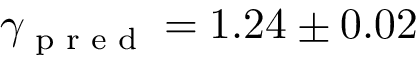Convert formula to latex. <formula><loc_0><loc_0><loc_500><loc_500>\gamma _ { p r e d } = 1 . 2 4 \pm 0 . 0 2</formula> 